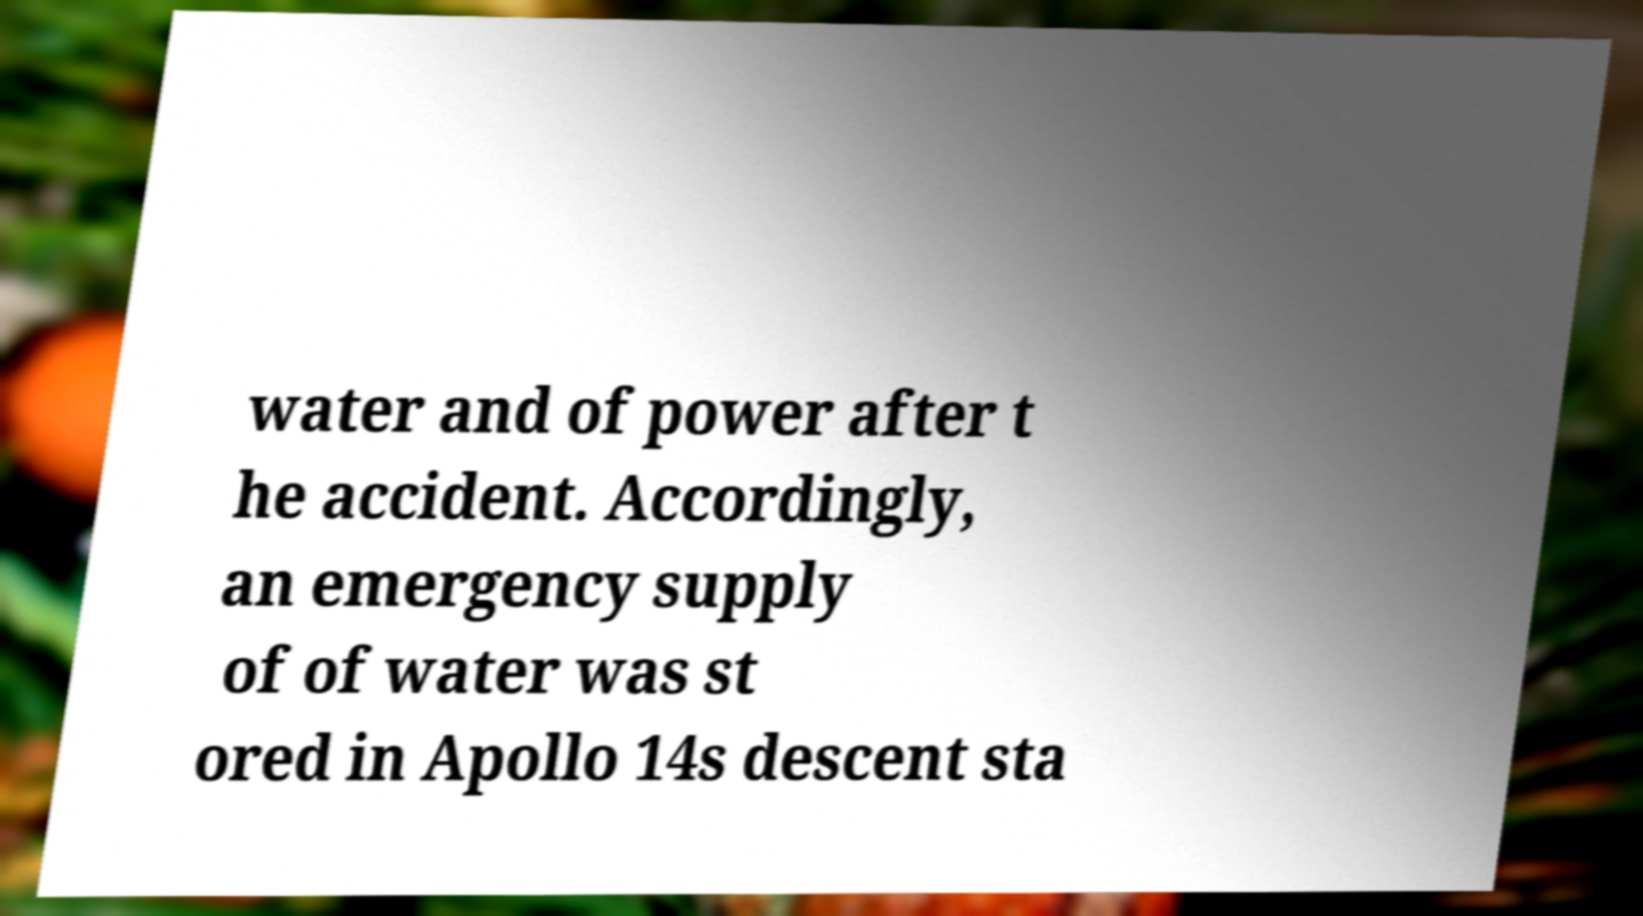Can you accurately transcribe the text from the provided image for me? water and of power after t he accident. Accordingly, an emergency supply of of water was st ored in Apollo 14s descent sta 